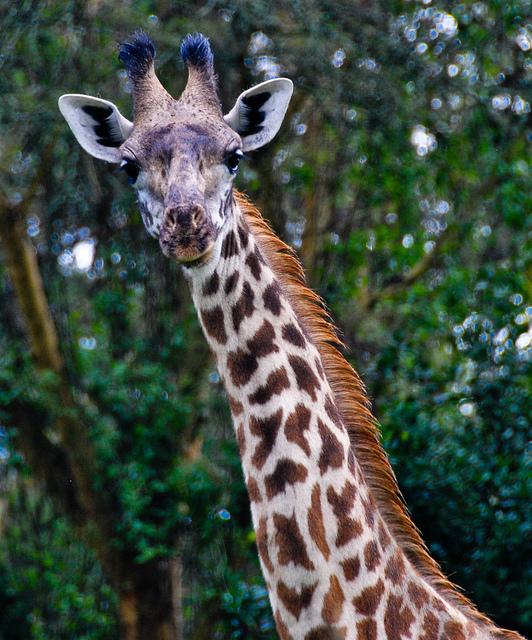What color is the tongue?
Quick response, please. Pink. Is the giraffe long?
Short answer required. Yes. How many animals are seen in the picture?
Short answer required. 1. What color are the trees?
Write a very short answer. Green. Is the giraffe looking up or down?
Short answer required. Down. Is this giraffe alone?
Concise answer only. Yes. 